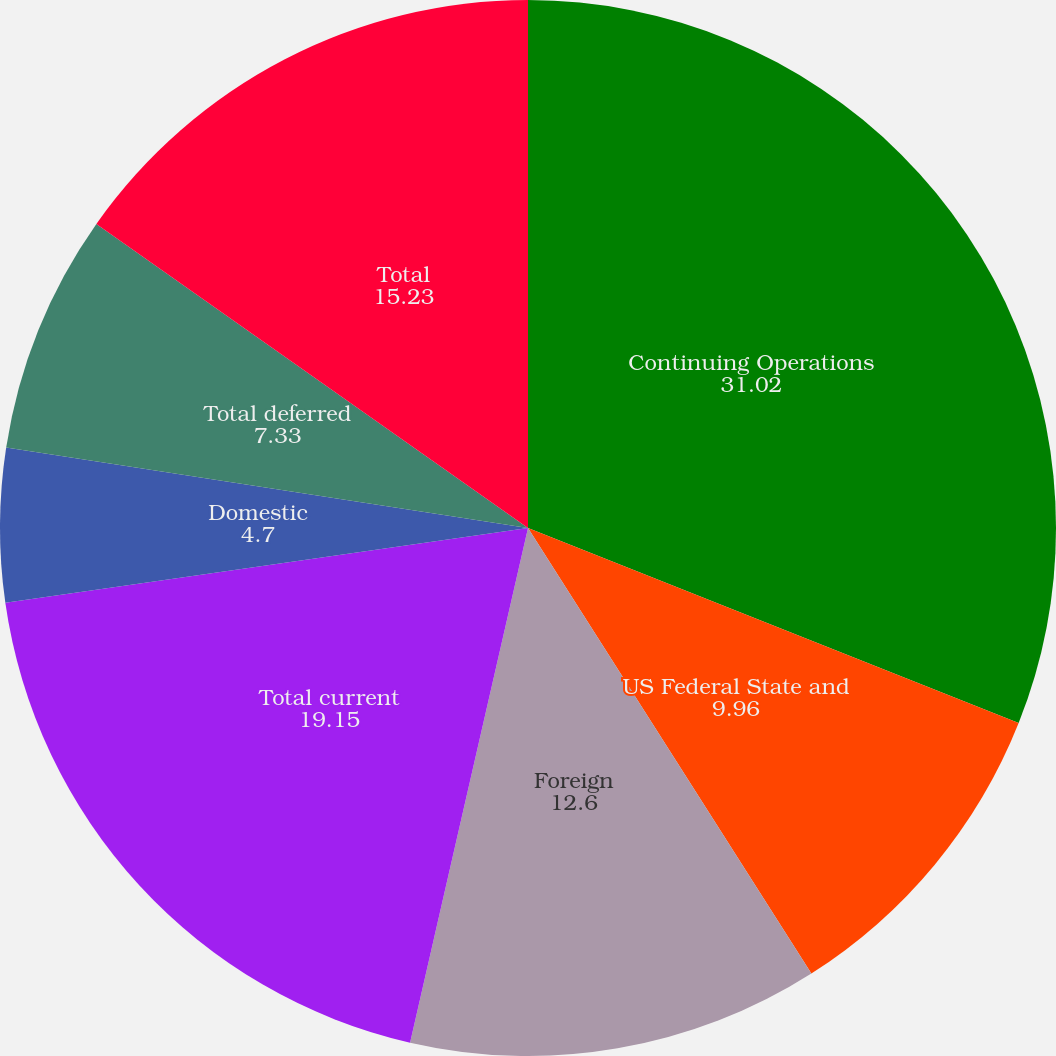Convert chart. <chart><loc_0><loc_0><loc_500><loc_500><pie_chart><fcel>Continuing Operations<fcel>US Federal State and<fcel>Foreign<fcel>Total current<fcel>Domestic<fcel>Total deferred<fcel>Total<nl><fcel>31.02%<fcel>9.96%<fcel>12.6%<fcel>19.15%<fcel>4.7%<fcel>7.33%<fcel>15.23%<nl></chart> 